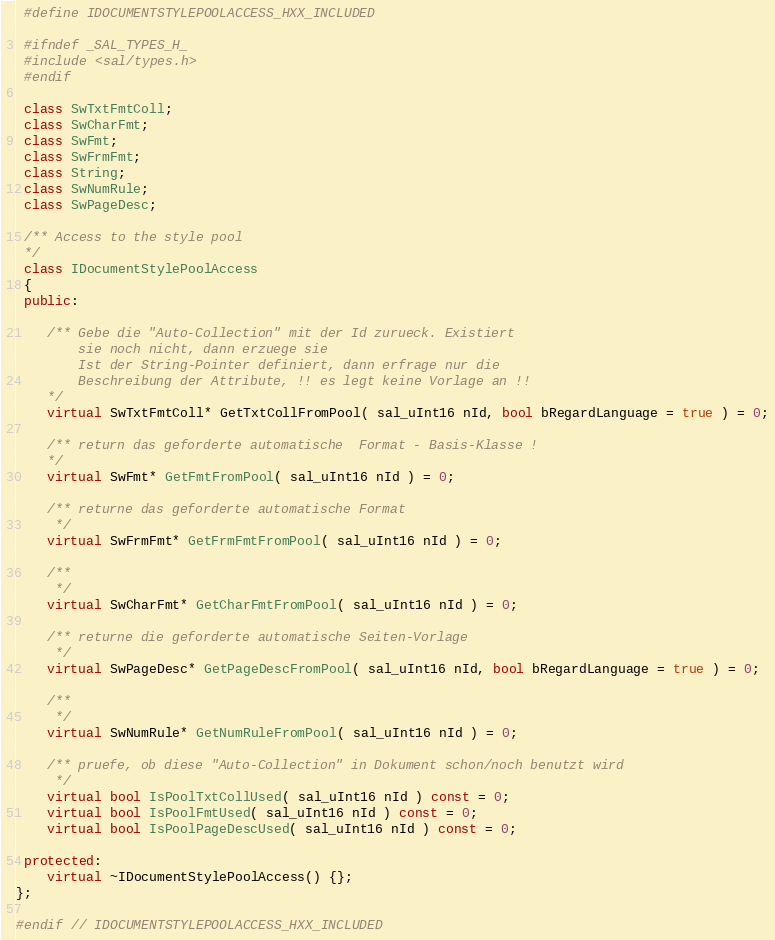<code> <loc_0><loc_0><loc_500><loc_500><_C++_> #define IDOCUMENTSTYLEPOOLACCESS_HXX_INCLUDED

 #ifndef _SAL_TYPES_H_
 #include <sal/types.h>
 #endif

 class SwTxtFmtColl;
 class SwCharFmt;
 class SwFmt;
 class SwFrmFmt;
 class String;
 class SwNumRule;
 class SwPageDesc;

 /** Access to the style pool
 */
 class IDocumentStylePoolAccess
 {
 public:

    /** Gebe die "Auto-Collection" mit der Id zurueck. Existiert
        sie noch nicht, dann erzuege sie
        Ist der String-Pointer definiert, dann erfrage nur die
        Beschreibung der Attribute, !! es legt keine Vorlage an !!
    */
    virtual SwTxtFmtColl* GetTxtCollFromPool( sal_uInt16 nId, bool bRegardLanguage = true ) = 0;

    /** return das geforderte automatische  Format - Basis-Klasse !
    */
    virtual SwFmt* GetFmtFromPool( sal_uInt16 nId ) = 0;

    /** returne das geforderte automatische Format
     */
    virtual SwFrmFmt* GetFrmFmtFromPool( sal_uInt16 nId ) = 0;

    /**
     */
    virtual SwCharFmt* GetCharFmtFromPool( sal_uInt16 nId ) = 0;

    /** returne die geforderte automatische Seiten-Vorlage
     */
    virtual SwPageDesc* GetPageDescFromPool( sal_uInt16 nId, bool bRegardLanguage = true ) = 0;

    /**
     */
    virtual SwNumRule* GetNumRuleFromPool( sal_uInt16 nId ) = 0;

    /** pruefe, ob diese "Auto-Collection" in Dokument schon/noch benutzt wird
     */
    virtual bool IsPoolTxtCollUsed( sal_uInt16 nId ) const = 0;
    virtual bool IsPoolFmtUsed( sal_uInt16 nId ) const = 0;
    virtual bool IsPoolPageDescUsed( sal_uInt16 nId ) const = 0;

 protected:
    virtual ~IDocumentStylePoolAccess() {};
};

#endif // IDOCUMENTSTYLEPOOLACCESS_HXX_INCLUDED

</code> 